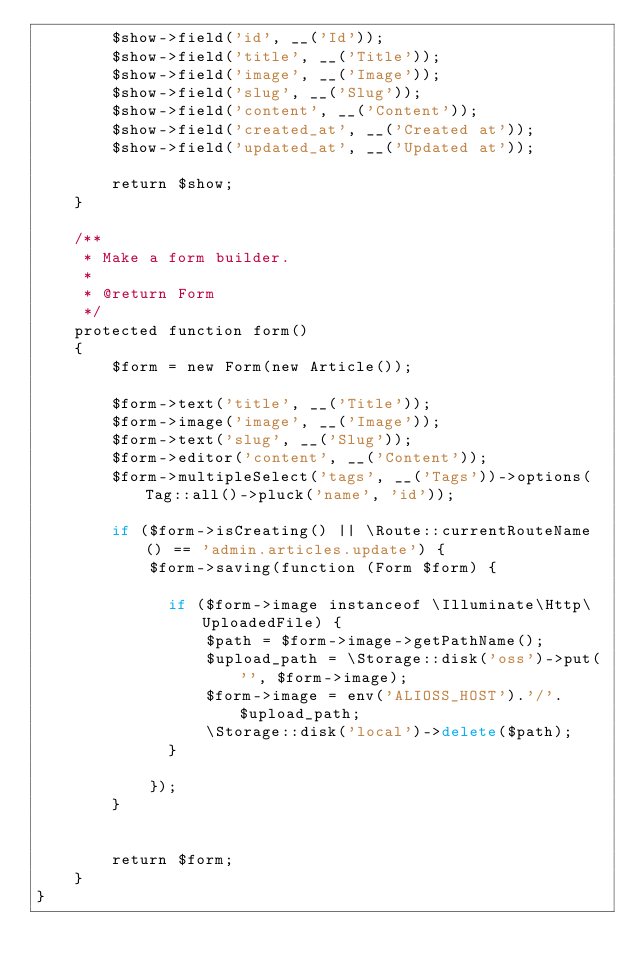<code> <loc_0><loc_0><loc_500><loc_500><_PHP_>        $show->field('id', __('Id'));
        $show->field('title', __('Title'));
        $show->field('image', __('Image'));
        $show->field('slug', __('Slug'));
        $show->field('content', __('Content'));
        $show->field('created_at', __('Created at'));
        $show->field('updated_at', __('Updated at'));

        return $show;
    }

    /**
     * Make a form builder.
     *
     * @return Form
     */
    protected function form()
    {
        $form = new Form(new Article());

        $form->text('title', __('Title'));
        $form->image('image', __('Image'));
        $form->text('slug', __('Slug'));
        $form->editor('content', __('Content'));
        $form->multipleSelect('tags', __('Tags'))->options(Tag::all()->pluck('name', 'id'));

        if ($form->isCreating() || \Route::currentRouteName() == 'admin.articles.update') {
            $form->saving(function (Form $form) {

	            if ($form->image instanceof \Illuminate\Http\UploadedFile) {
	                $path = $form->image->getPathName();
	                $upload_path = \Storage::disk('oss')->put('', $form->image);
	                $form->image = env('ALIOSS_HOST').'/'.$upload_path;
	                \Storage::disk('local')->delete($path);
	            }

            });
        }


        return $form;
    }
}
</code> 